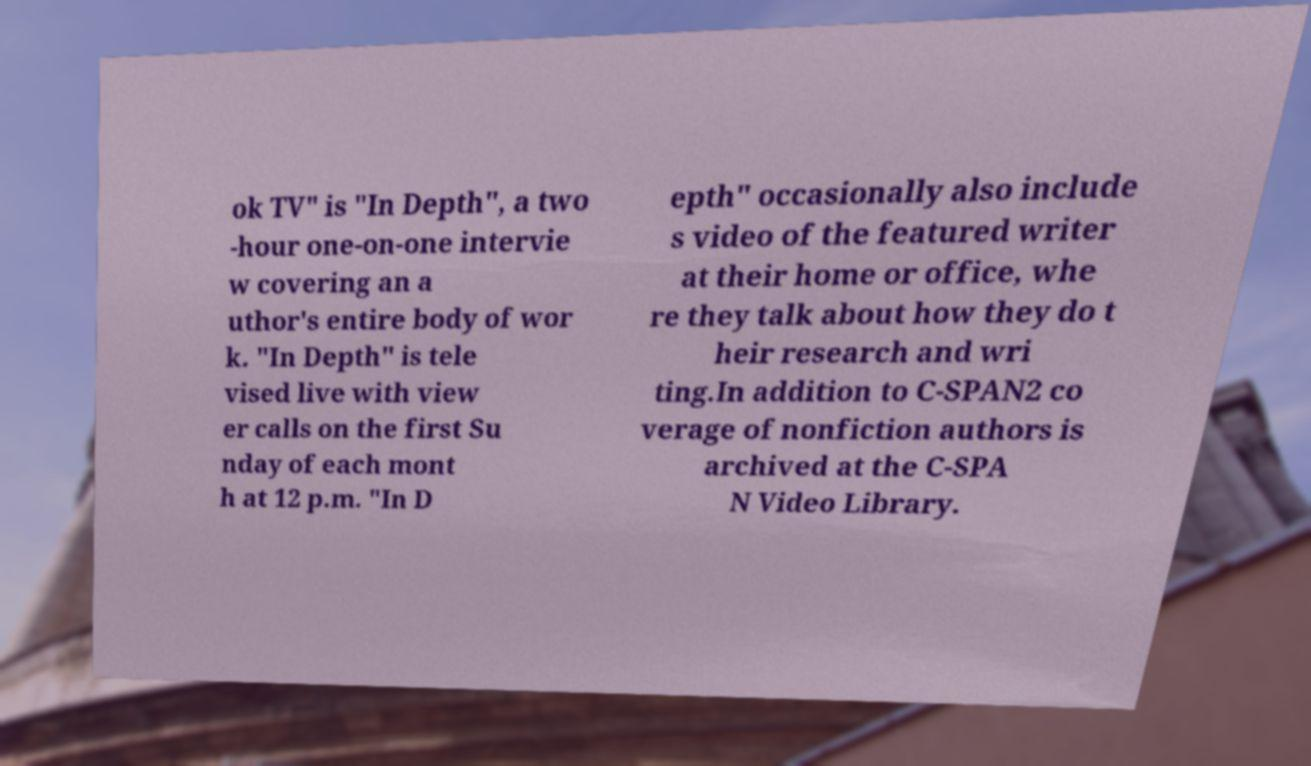Can you read and provide the text displayed in the image?This photo seems to have some interesting text. Can you extract and type it out for me? ok TV" is "In Depth", a two -hour one-on-one intervie w covering an a uthor's entire body of wor k. "In Depth" is tele vised live with view er calls on the first Su nday of each mont h at 12 p.m. "In D epth" occasionally also include s video of the featured writer at their home or office, whe re they talk about how they do t heir research and wri ting.In addition to C-SPAN2 co verage of nonfiction authors is archived at the C-SPA N Video Library. 